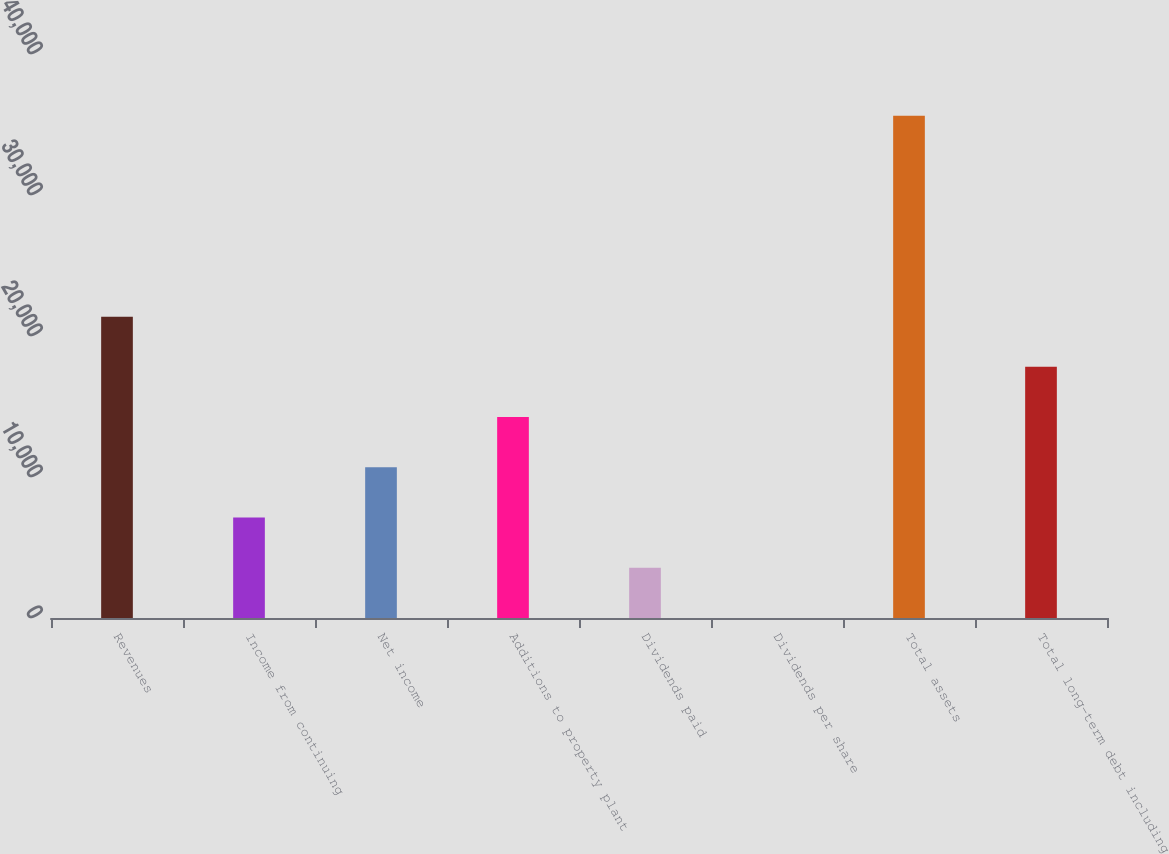Convert chart. <chart><loc_0><loc_0><loc_500><loc_500><bar_chart><fcel>Revenues<fcel>Income from continuing<fcel>Net income<fcel>Additions to property plant<fcel>Dividends paid<fcel>Dividends per share<fcel>Total assets<fcel>Total long-term debt including<nl><fcel>21372.3<fcel>7124.58<fcel>10686.5<fcel>14248.4<fcel>3562.65<fcel>0.72<fcel>35620<fcel>17810.4<nl></chart> 